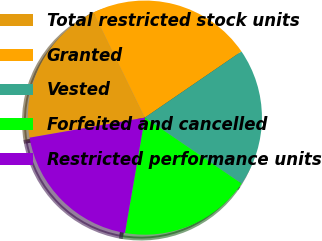<chart> <loc_0><loc_0><loc_500><loc_500><pie_chart><fcel>Total restricted stock units<fcel>Granted<fcel>Vested<fcel>Forfeited and cancelled<fcel>Restricted performance units<nl><fcel>20.52%<fcel>22.67%<fcel>19.09%<fcel>18.19%<fcel>19.54%<nl></chart> 